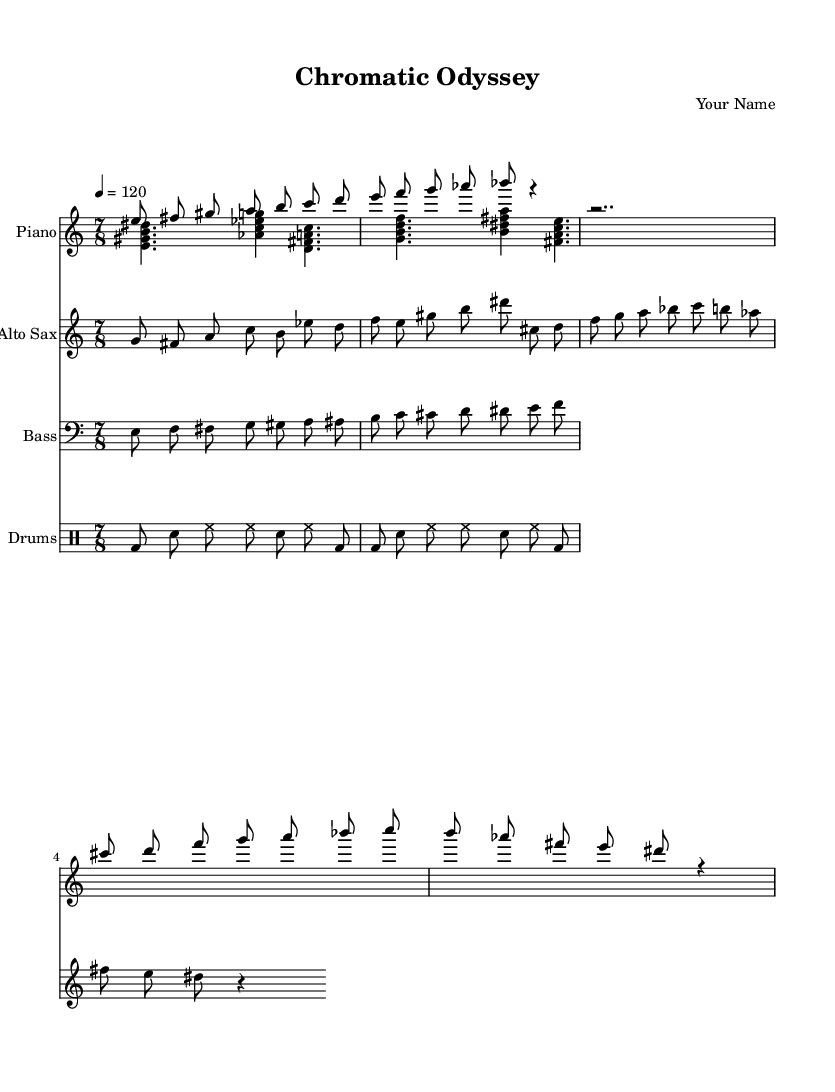What is the time signature of this music? The time signature specified in the global settings is 7/8, which means there are 7 beats in each measure, and the eighth note gets one beat.
Answer: 7/8 What is the key signature of this music? The key signature is C major, which is indicated by having no sharps or flats in the key signature section of the music.
Answer: C major What is the tempo marking of this music? The tempo marking indicates a speed of 120 beats per minute with the marking "4 = 120", where '4' refers to the quarter note.
Answer: 120 How many themes are presented in this piece? Two distinct themes are indicated: Theme A and Theme B, both labeled in the piano section and also appearing in the saxophone part.
Answer: Two Which instrument plays the walking bass line? The bass instrument is responsible for playing the walking bass line, as seen in the bass staff part of the score.
Answer: Bass How are the drums structured in terms of groove? The drumming pattern emphasizes the first and sixth eighth notes within the groove, creating a distinctive rhythmic feel in the piece.
Answer: Emphasis on 1st and 6th eighth notes What type of improvisation is featured in this composition? The score incorporates improvisation within the themes, especially noted in the saxophone part where it varies alongside the piano.
Answer: Improvisation 